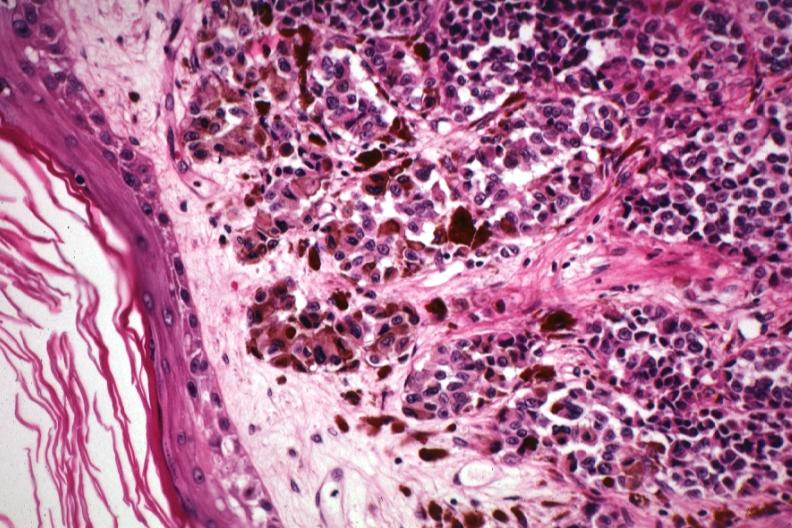does this image show excellent showing lesion just beneath epidermis with pigmented and non-pigmented cells?
Answer the question using a single word or phrase. Yes 